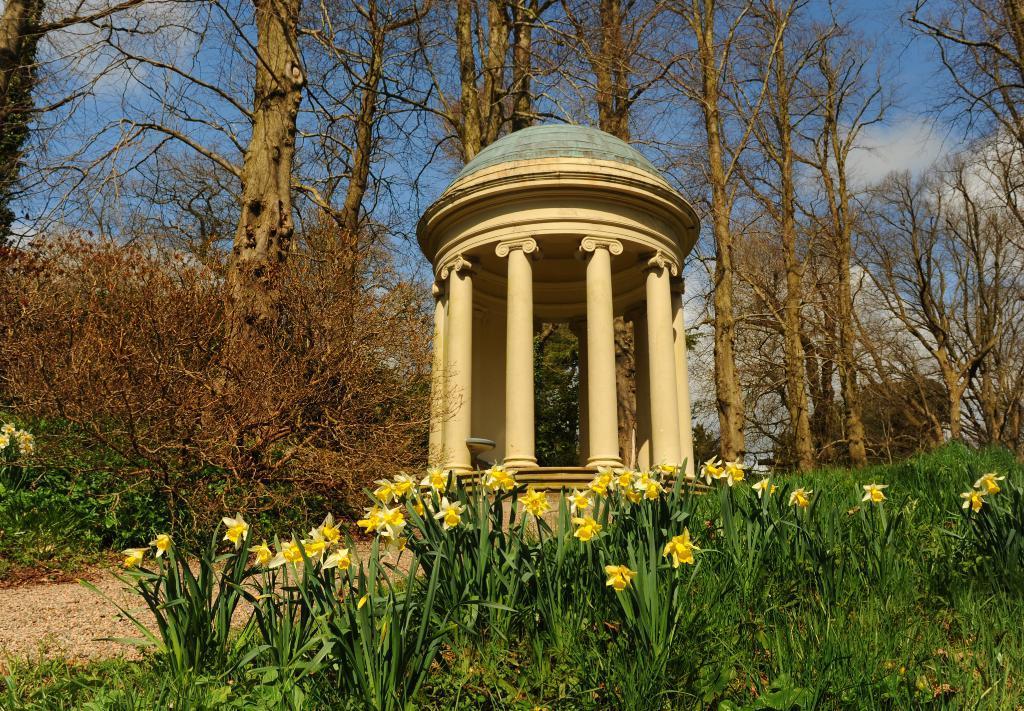In one or two sentences, can you explain what this image depicts? In this picture I can see the monument, beside that I can see the trees, plants and grass. At the bottom I can see the yellow flowers and plants. At the top I can see the sky and clouds. 